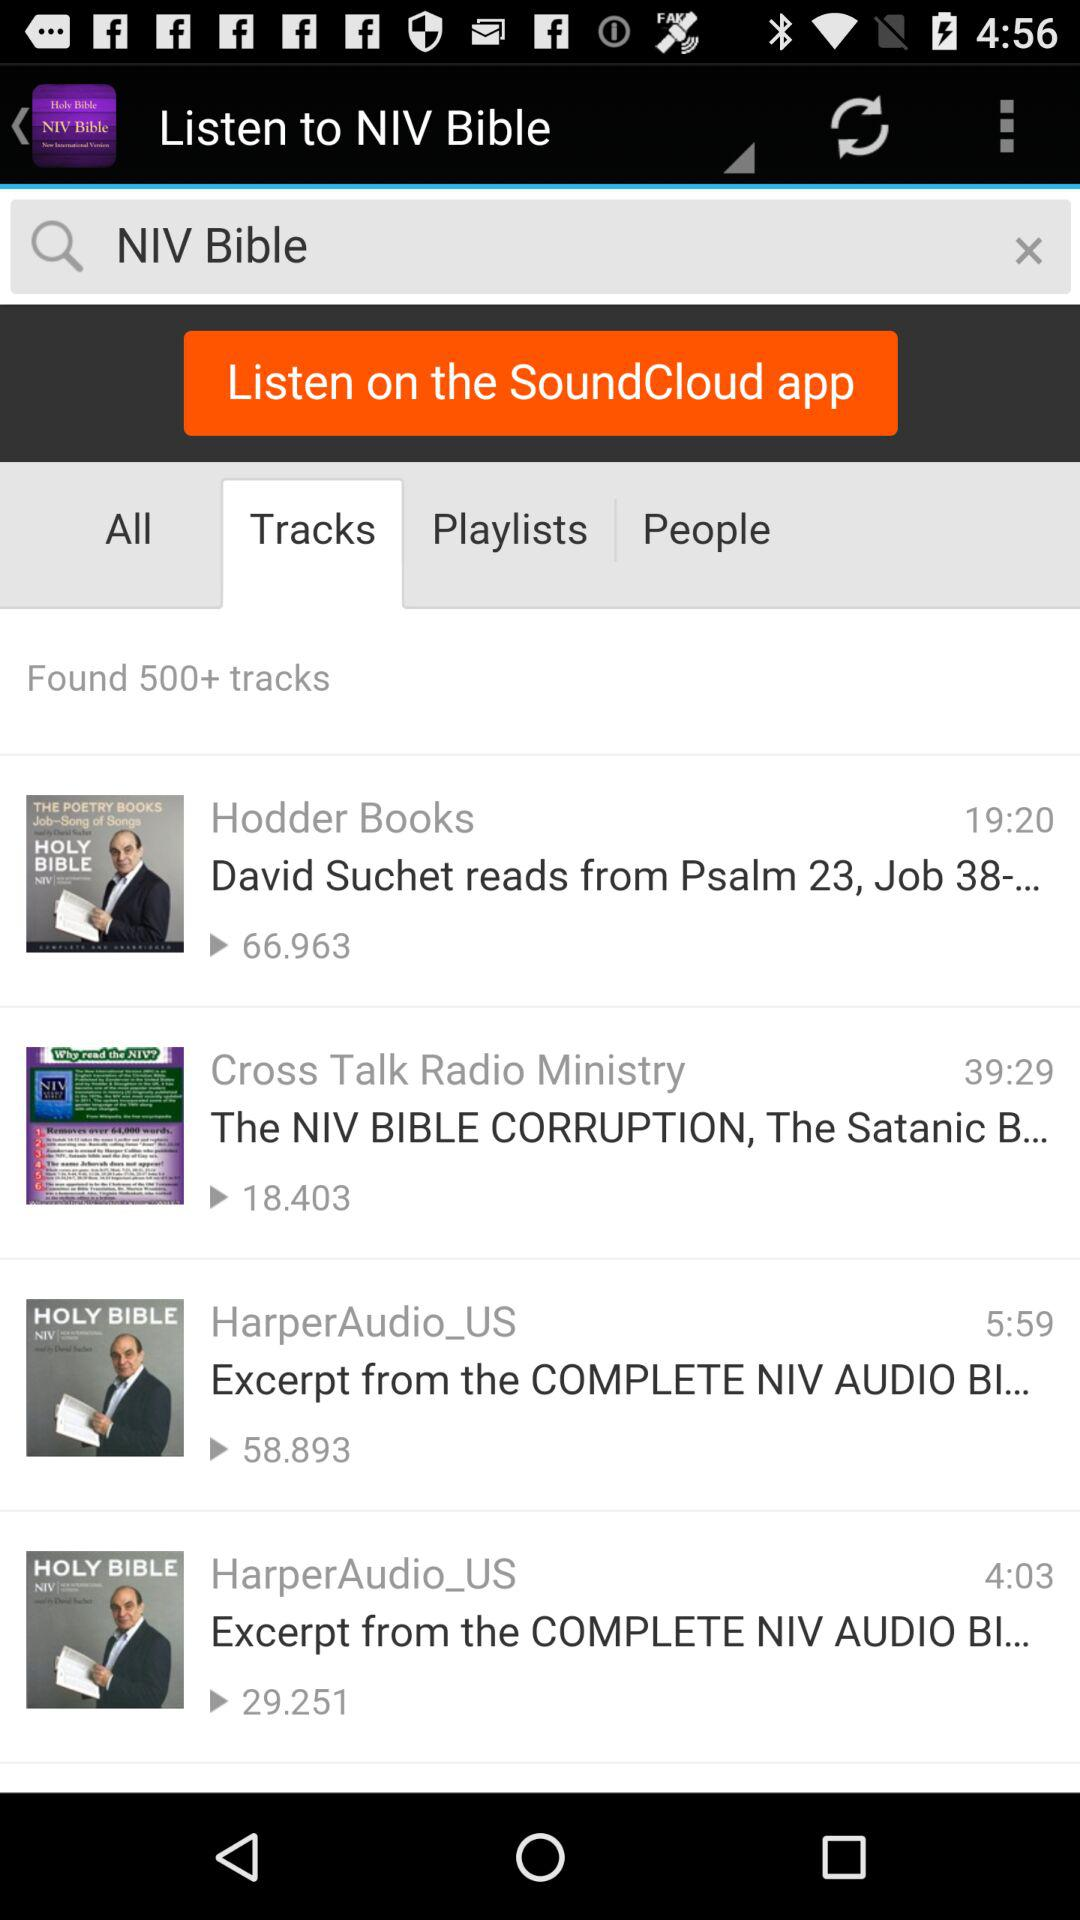What is the length of the audio "Hodder books"? The length of the audio "Hodder books" is 19 minutes 20 seconds. 